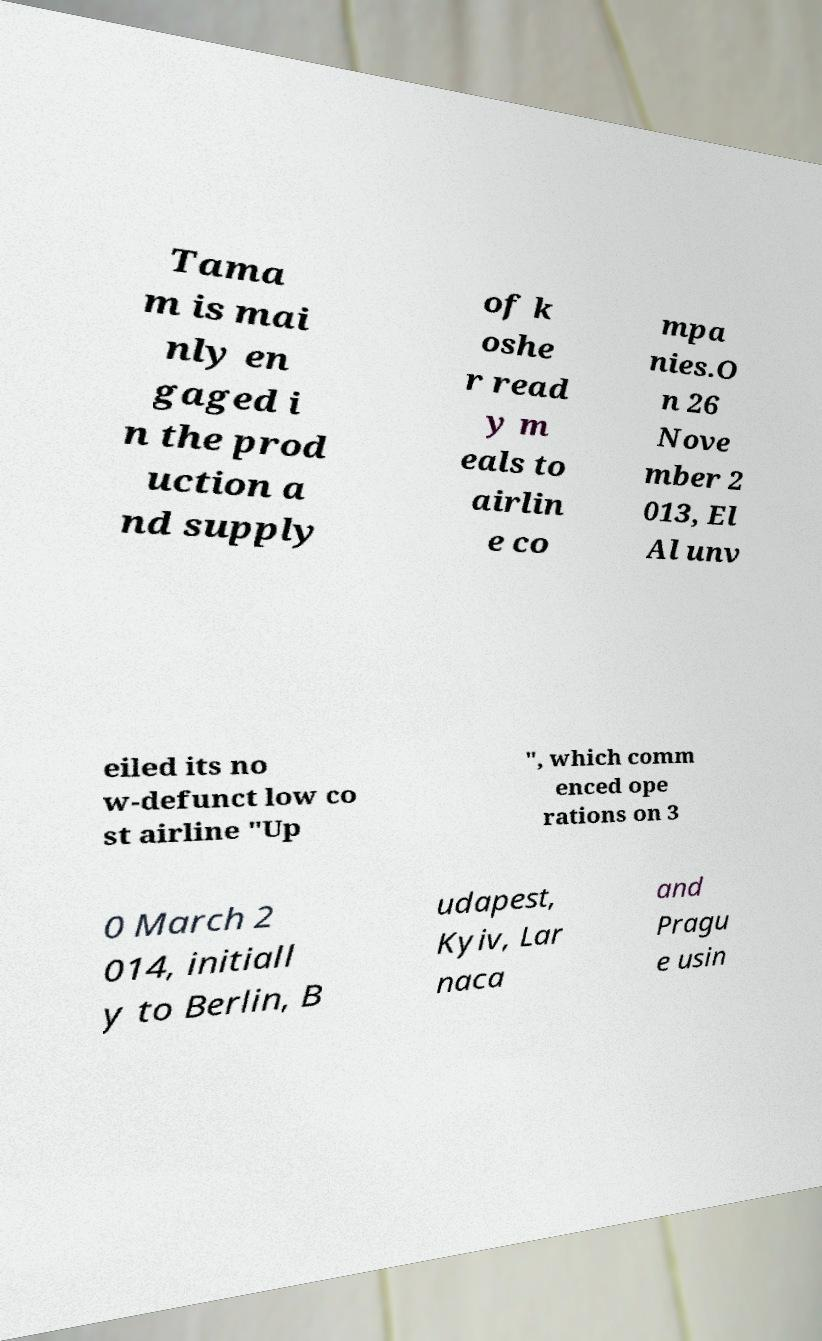I need the written content from this picture converted into text. Can you do that? Tama m is mai nly en gaged i n the prod uction a nd supply of k oshe r read y m eals to airlin e co mpa nies.O n 26 Nove mber 2 013, El Al unv eiled its no w-defunct low co st airline "Up ", which comm enced ope rations on 3 0 March 2 014, initiall y to Berlin, B udapest, Kyiv, Lar naca and Pragu e usin 